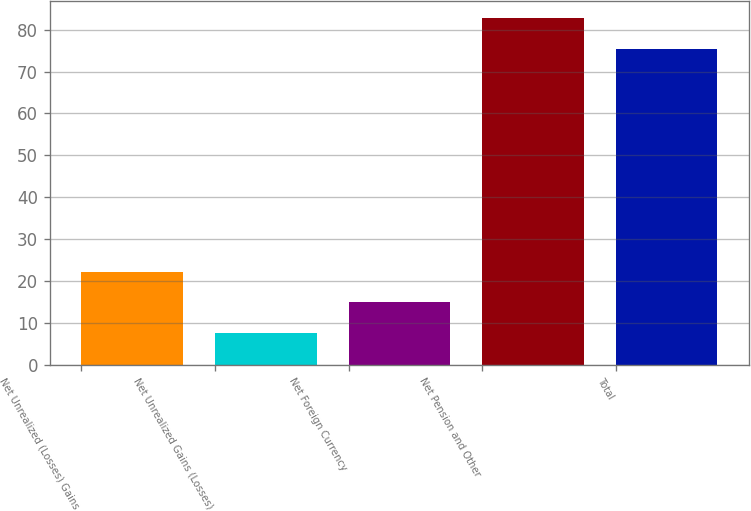Convert chart. <chart><loc_0><loc_0><loc_500><loc_500><bar_chart><fcel>Net Unrealized (Losses) Gains<fcel>Net Unrealized Gains (Losses)<fcel>Net Foreign Currency<fcel>Net Pension and Other<fcel>Total<nl><fcel>22.2<fcel>7.6<fcel>14.9<fcel>82.7<fcel>75.4<nl></chart> 